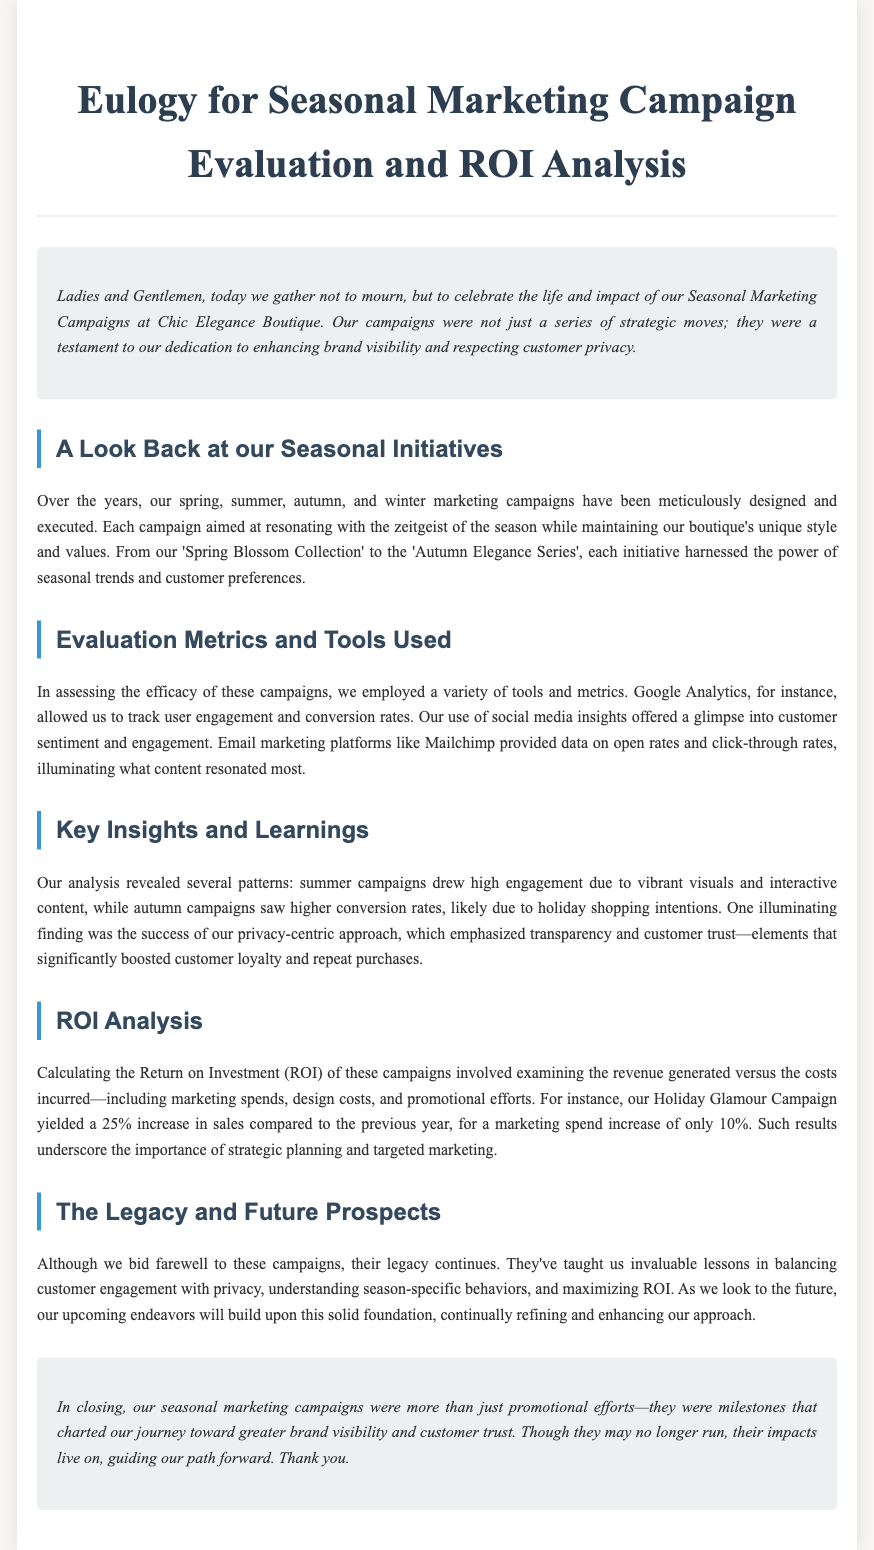What was the title of the eulogy? The title of the eulogy is provided in the document's header.
Answer: Eulogy for Seasonal Marketing Campaign Evaluation and ROI Analysis Which metrics were used to track engagement? The document mentions specific tools for tracking user engagement in campaigns.
Answer: Google Analytics, social media insights, Mailchimp What was the increase in sales from the Holiday Glamour Campaign? The document states the percentage increase in sales related to the Holiday Glamour Campaign.
Answer: 25% What marketing strategy was emphasized to boost customer loyalty? The document highlights a specific approach that contributed to enhancing customer trust and loyalty.
Answer: Privacy-centric approach What was the percentage increase in marketing spending for the Holiday Glamour Campaign? The document specifies the increase in marketing spending associated with the Holiday Glamour Campaign.
Answer: 10% What seasonal campaign had high engagement due to vibrant visuals? The document identifies a specific season where campaigns were more engaging based on visual content.
Answer: Summer campaigns Which section discusses the future prospects of seasonal campaigns? The document contains a specific section dedicated to future plans based on past campaigns.
Answer: The Legacy and Future Prospects What tone does the eulogy convey regarding seasonal marketing campaigns? The introduction clarifies the overall tone and intent of the eulogy.
Answer: Celebrate 